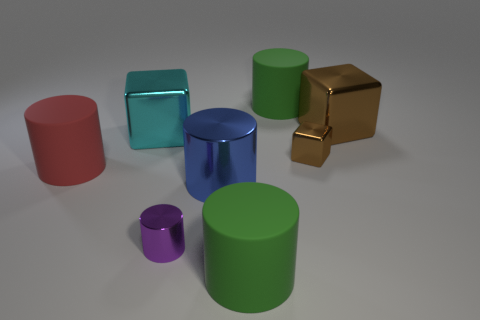Can you describe the colors of the objects and their spatial arrangement in the scene? Certainly! In the scene, you can observe objects boasting a variety of hues including red, blue, green, gold, and purple. They are arranged somewhat haphazardly on a flat surface, with cylinders and cubes alike creating an almost playful display of three-dimensional geometric shapes. 